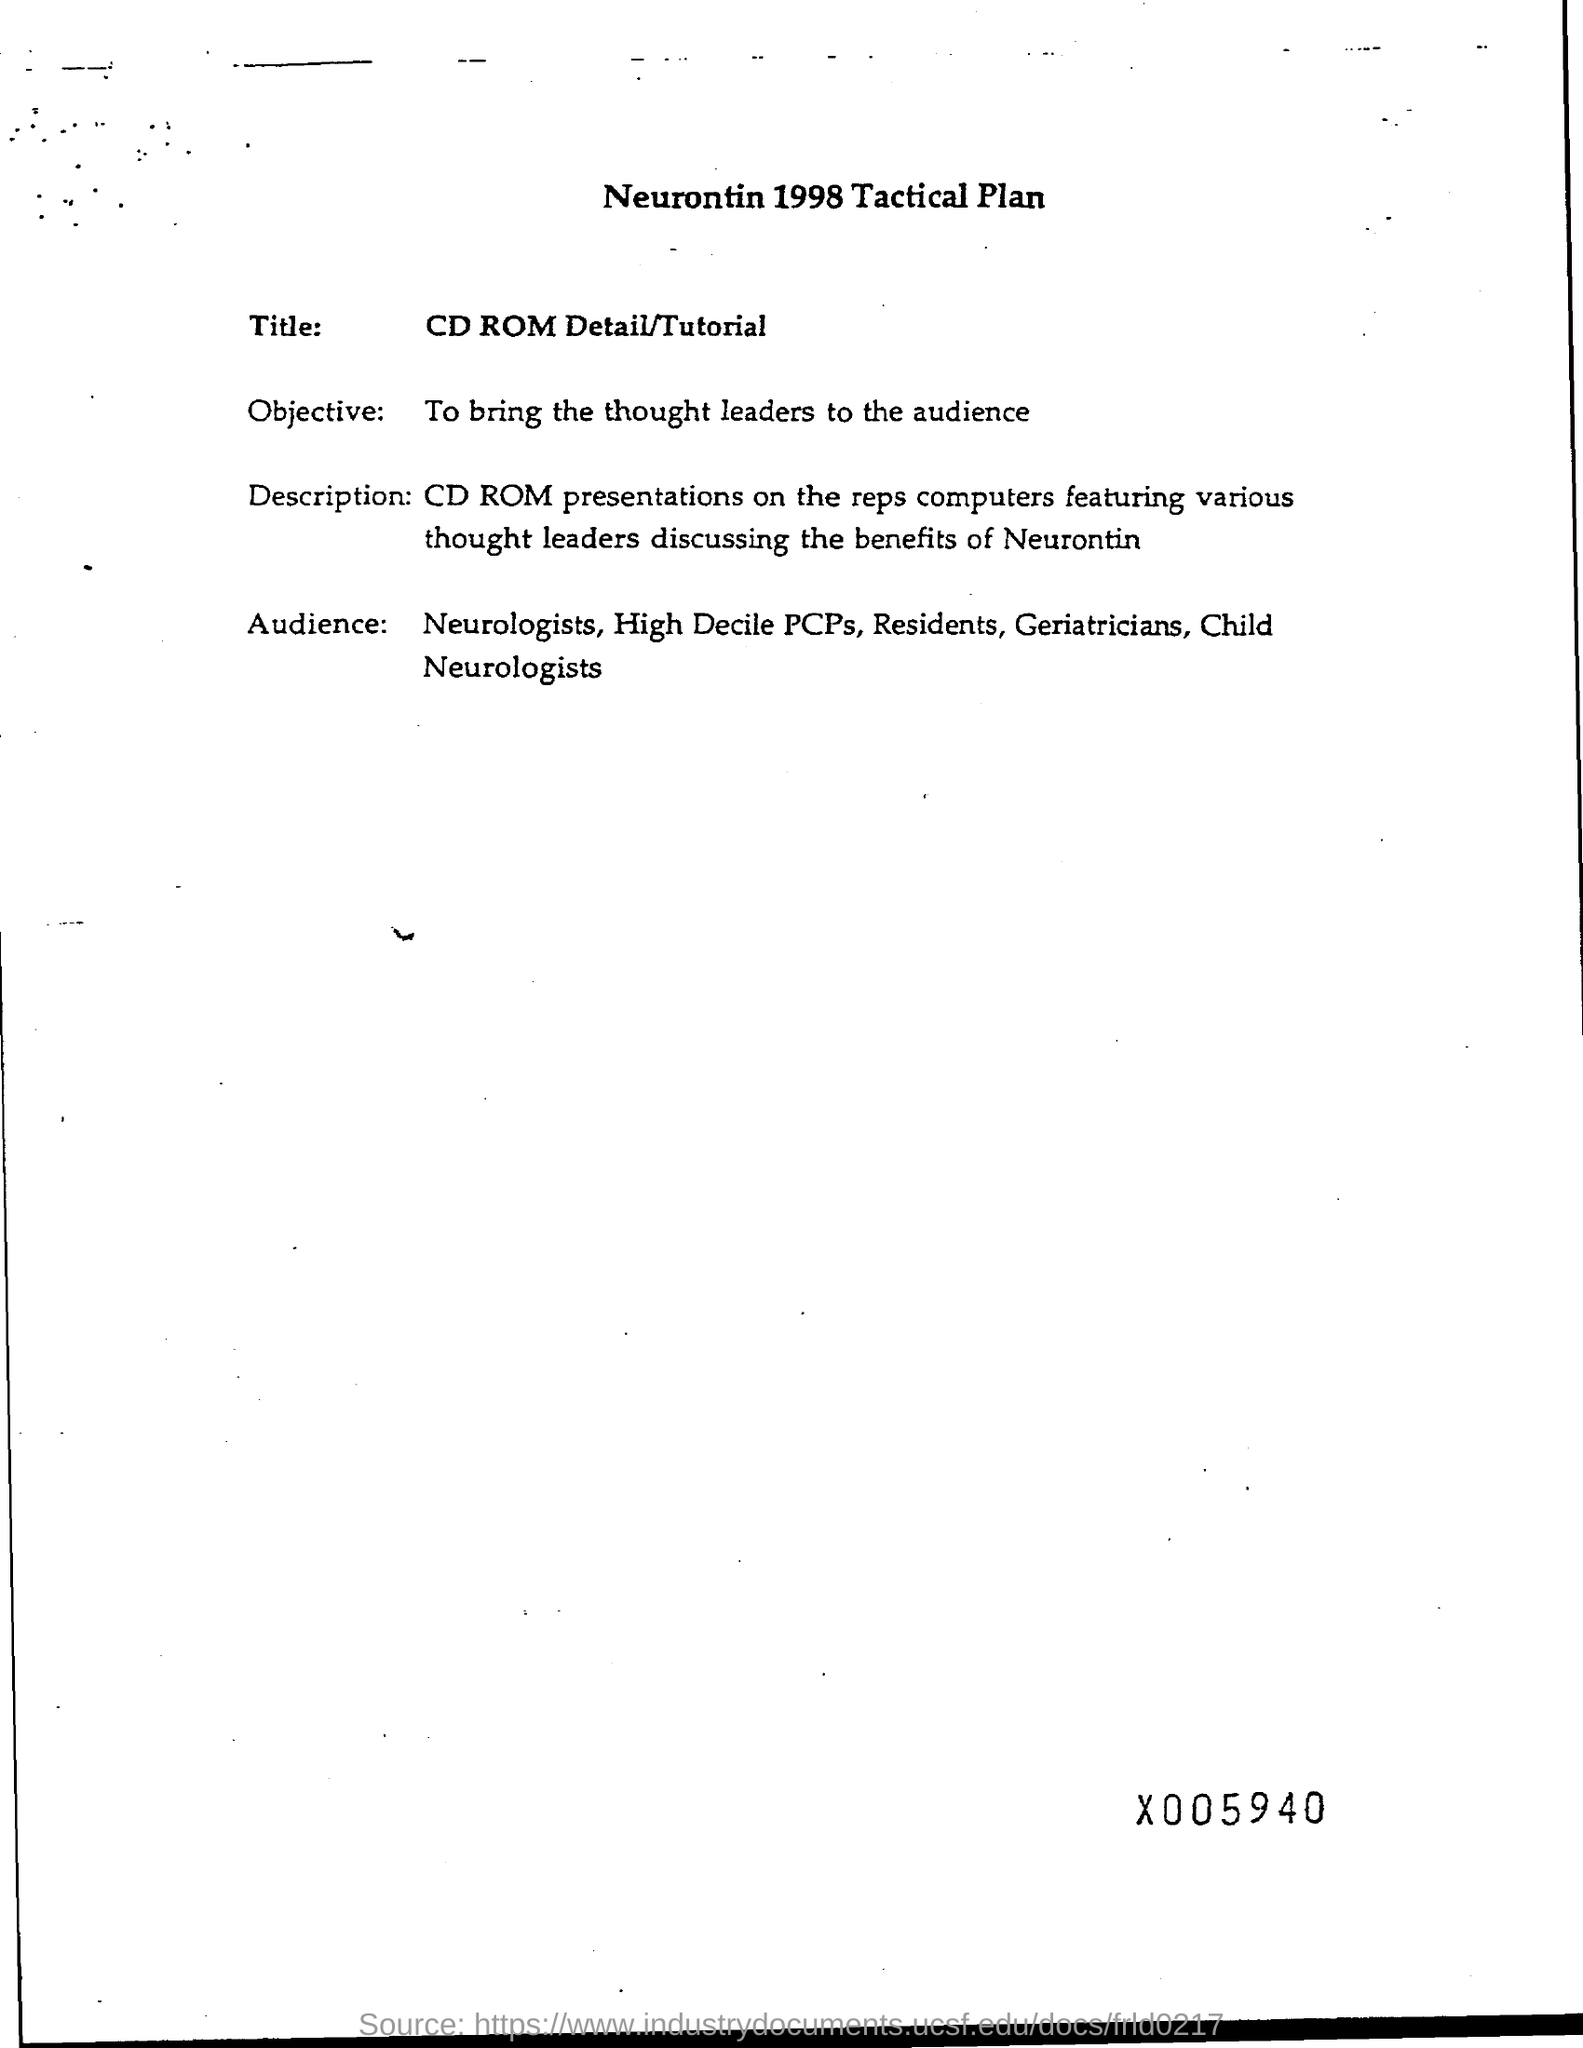What is the title ?
Offer a terse response. CD Rom Detail/ Tutorial. 